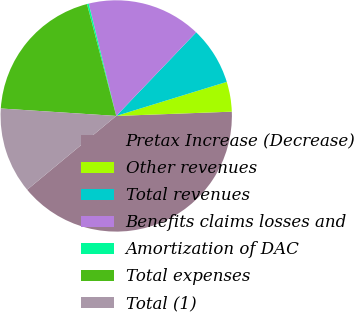Convert chart to OTSL. <chart><loc_0><loc_0><loc_500><loc_500><pie_chart><fcel>Pretax Increase (Decrease)<fcel>Other revenues<fcel>Total revenues<fcel>Benefits claims losses and<fcel>Amortization of DAC<fcel>Total expenses<fcel>Total (1)<nl><fcel>39.58%<fcel>4.17%<fcel>8.1%<fcel>15.97%<fcel>0.24%<fcel>19.91%<fcel>12.04%<nl></chart> 